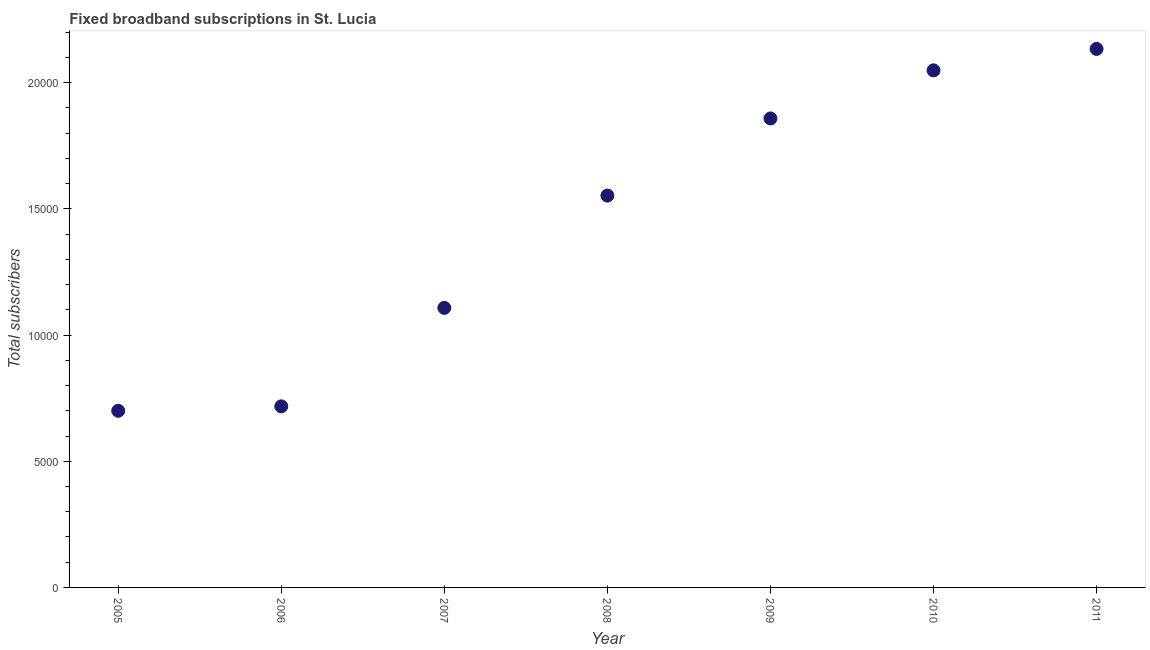What is the total number of fixed broadband subscriptions in 2011?
Offer a very short reply. 2.13e+04. Across all years, what is the maximum total number of fixed broadband subscriptions?
Give a very brief answer. 2.13e+04. Across all years, what is the minimum total number of fixed broadband subscriptions?
Your answer should be compact. 7000. In which year was the total number of fixed broadband subscriptions maximum?
Provide a succinct answer. 2011. In which year was the total number of fixed broadband subscriptions minimum?
Give a very brief answer. 2005. What is the sum of the total number of fixed broadband subscriptions?
Give a very brief answer. 1.01e+05. What is the difference between the total number of fixed broadband subscriptions in 2010 and 2011?
Your response must be concise. -849. What is the average total number of fixed broadband subscriptions per year?
Give a very brief answer. 1.45e+04. What is the median total number of fixed broadband subscriptions?
Offer a terse response. 1.55e+04. In how many years, is the total number of fixed broadband subscriptions greater than 20000 ?
Keep it short and to the point. 2. Do a majority of the years between 2009 and 2010 (inclusive) have total number of fixed broadband subscriptions greater than 4000 ?
Your response must be concise. Yes. What is the ratio of the total number of fixed broadband subscriptions in 2008 to that in 2010?
Keep it short and to the point. 0.76. Is the difference between the total number of fixed broadband subscriptions in 2006 and 2011 greater than the difference between any two years?
Give a very brief answer. No. What is the difference between the highest and the second highest total number of fixed broadband subscriptions?
Ensure brevity in your answer.  849. Is the sum of the total number of fixed broadband subscriptions in 2005 and 2007 greater than the maximum total number of fixed broadband subscriptions across all years?
Keep it short and to the point. No. What is the difference between the highest and the lowest total number of fixed broadband subscriptions?
Provide a succinct answer. 1.43e+04. Does the total number of fixed broadband subscriptions monotonically increase over the years?
Keep it short and to the point. Yes. How many dotlines are there?
Your response must be concise. 1. How many years are there in the graph?
Your answer should be very brief. 7. What is the difference between two consecutive major ticks on the Y-axis?
Provide a succinct answer. 5000. Are the values on the major ticks of Y-axis written in scientific E-notation?
Offer a very short reply. No. Does the graph contain grids?
Keep it short and to the point. No. What is the title of the graph?
Offer a terse response. Fixed broadband subscriptions in St. Lucia. What is the label or title of the X-axis?
Your response must be concise. Year. What is the label or title of the Y-axis?
Give a very brief answer. Total subscribers. What is the Total subscribers in 2005?
Your response must be concise. 7000. What is the Total subscribers in 2006?
Provide a short and direct response. 7176. What is the Total subscribers in 2007?
Give a very brief answer. 1.11e+04. What is the Total subscribers in 2008?
Your answer should be very brief. 1.55e+04. What is the Total subscribers in 2009?
Provide a succinct answer. 1.86e+04. What is the Total subscribers in 2010?
Offer a very short reply. 2.05e+04. What is the Total subscribers in 2011?
Offer a terse response. 2.13e+04. What is the difference between the Total subscribers in 2005 and 2006?
Provide a succinct answer. -176. What is the difference between the Total subscribers in 2005 and 2007?
Give a very brief answer. -4078. What is the difference between the Total subscribers in 2005 and 2008?
Provide a short and direct response. -8527. What is the difference between the Total subscribers in 2005 and 2009?
Your response must be concise. -1.16e+04. What is the difference between the Total subscribers in 2005 and 2010?
Keep it short and to the point. -1.35e+04. What is the difference between the Total subscribers in 2005 and 2011?
Provide a succinct answer. -1.43e+04. What is the difference between the Total subscribers in 2006 and 2007?
Your response must be concise. -3902. What is the difference between the Total subscribers in 2006 and 2008?
Provide a succinct answer. -8351. What is the difference between the Total subscribers in 2006 and 2009?
Give a very brief answer. -1.14e+04. What is the difference between the Total subscribers in 2006 and 2010?
Your answer should be compact. -1.33e+04. What is the difference between the Total subscribers in 2006 and 2011?
Your response must be concise. -1.42e+04. What is the difference between the Total subscribers in 2007 and 2008?
Give a very brief answer. -4449. What is the difference between the Total subscribers in 2007 and 2009?
Your response must be concise. -7508. What is the difference between the Total subscribers in 2007 and 2010?
Offer a very short reply. -9413. What is the difference between the Total subscribers in 2007 and 2011?
Ensure brevity in your answer.  -1.03e+04. What is the difference between the Total subscribers in 2008 and 2009?
Offer a terse response. -3059. What is the difference between the Total subscribers in 2008 and 2010?
Offer a terse response. -4964. What is the difference between the Total subscribers in 2008 and 2011?
Provide a succinct answer. -5813. What is the difference between the Total subscribers in 2009 and 2010?
Ensure brevity in your answer.  -1905. What is the difference between the Total subscribers in 2009 and 2011?
Keep it short and to the point. -2754. What is the difference between the Total subscribers in 2010 and 2011?
Keep it short and to the point. -849. What is the ratio of the Total subscribers in 2005 to that in 2007?
Keep it short and to the point. 0.63. What is the ratio of the Total subscribers in 2005 to that in 2008?
Your response must be concise. 0.45. What is the ratio of the Total subscribers in 2005 to that in 2009?
Keep it short and to the point. 0.38. What is the ratio of the Total subscribers in 2005 to that in 2010?
Provide a succinct answer. 0.34. What is the ratio of the Total subscribers in 2005 to that in 2011?
Your answer should be very brief. 0.33. What is the ratio of the Total subscribers in 2006 to that in 2007?
Your response must be concise. 0.65. What is the ratio of the Total subscribers in 2006 to that in 2008?
Offer a terse response. 0.46. What is the ratio of the Total subscribers in 2006 to that in 2009?
Offer a terse response. 0.39. What is the ratio of the Total subscribers in 2006 to that in 2011?
Your answer should be very brief. 0.34. What is the ratio of the Total subscribers in 2007 to that in 2008?
Give a very brief answer. 0.71. What is the ratio of the Total subscribers in 2007 to that in 2009?
Provide a succinct answer. 0.6. What is the ratio of the Total subscribers in 2007 to that in 2010?
Your answer should be very brief. 0.54. What is the ratio of the Total subscribers in 2007 to that in 2011?
Provide a succinct answer. 0.52. What is the ratio of the Total subscribers in 2008 to that in 2009?
Offer a terse response. 0.83. What is the ratio of the Total subscribers in 2008 to that in 2010?
Your response must be concise. 0.76. What is the ratio of the Total subscribers in 2008 to that in 2011?
Provide a succinct answer. 0.73. What is the ratio of the Total subscribers in 2009 to that in 2010?
Offer a very short reply. 0.91. What is the ratio of the Total subscribers in 2009 to that in 2011?
Offer a very short reply. 0.87. What is the ratio of the Total subscribers in 2010 to that in 2011?
Offer a terse response. 0.96. 